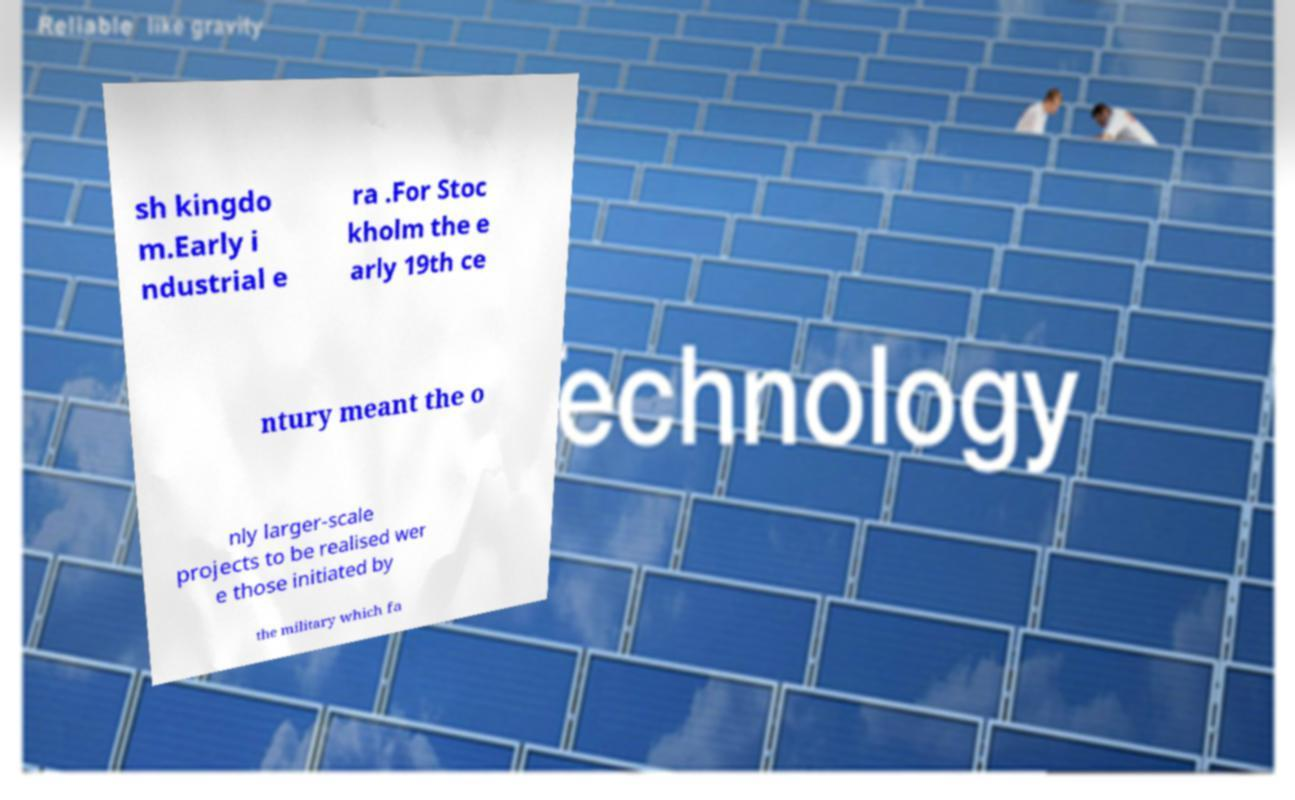Can you read and provide the text displayed in the image?This photo seems to have some interesting text. Can you extract and type it out for me? sh kingdo m.Early i ndustrial e ra .For Stoc kholm the e arly 19th ce ntury meant the o nly larger-scale projects to be realised wer e those initiated by the military which fa 